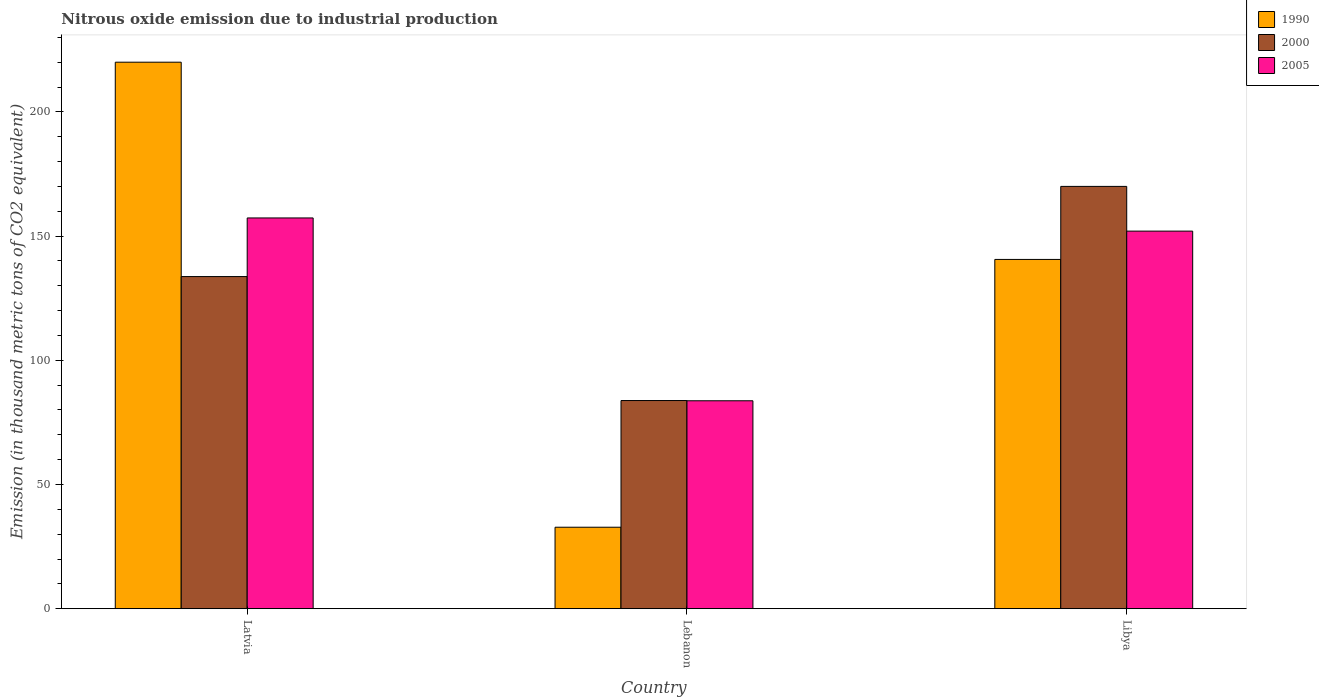How many different coloured bars are there?
Make the answer very short. 3. Are the number of bars per tick equal to the number of legend labels?
Make the answer very short. Yes. Are the number of bars on each tick of the X-axis equal?
Your response must be concise. Yes. How many bars are there on the 1st tick from the left?
Ensure brevity in your answer.  3. How many bars are there on the 1st tick from the right?
Your response must be concise. 3. What is the label of the 3rd group of bars from the left?
Provide a short and direct response. Libya. In how many cases, is the number of bars for a given country not equal to the number of legend labels?
Ensure brevity in your answer.  0. What is the amount of nitrous oxide emitted in 2000 in Latvia?
Provide a short and direct response. 133.7. Across all countries, what is the maximum amount of nitrous oxide emitted in 2000?
Your answer should be compact. 170. Across all countries, what is the minimum amount of nitrous oxide emitted in 2000?
Provide a succinct answer. 83.8. In which country was the amount of nitrous oxide emitted in 1990 maximum?
Your answer should be compact. Latvia. In which country was the amount of nitrous oxide emitted in 2005 minimum?
Keep it short and to the point. Lebanon. What is the total amount of nitrous oxide emitted in 2000 in the graph?
Your answer should be compact. 387.5. What is the difference between the amount of nitrous oxide emitted in 1990 in Lebanon and that in Libya?
Provide a succinct answer. -107.8. What is the difference between the amount of nitrous oxide emitted in 2005 in Lebanon and the amount of nitrous oxide emitted in 1990 in Libya?
Make the answer very short. -56.9. What is the average amount of nitrous oxide emitted in 1990 per country?
Your answer should be compact. 131.13. What is the difference between the amount of nitrous oxide emitted of/in 1990 and amount of nitrous oxide emitted of/in 2005 in Libya?
Your answer should be compact. -11.4. What is the ratio of the amount of nitrous oxide emitted in 2005 in Latvia to that in Libya?
Provide a short and direct response. 1.03. Is the difference between the amount of nitrous oxide emitted in 1990 in Lebanon and Libya greater than the difference between the amount of nitrous oxide emitted in 2005 in Lebanon and Libya?
Provide a succinct answer. No. What is the difference between the highest and the second highest amount of nitrous oxide emitted in 2005?
Your response must be concise. 68.3. What is the difference between the highest and the lowest amount of nitrous oxide emitted in 2000?
Provide a succinct answer. 86.2. What does the 2nd bar from the right in Latvia represents?
Ensure brevity in your answer.  2000. How many bars are there?
Give a very brief answer. 9. Are all the bars in the graph horizontal?
Your answer should be compact. No. How many countries are there in the graph?
Ensure brevity in your answer.  3. Does the graph contain any zero values?
Your answer should be compact. No. How are the legend labels stacked?
Give a very brief answer. Vertical. What is the title of the graph?
Give a very brief answer. Nitrous oxide emission due to industrial production. Does "1976" appear as one of the legend labels in the graph?
Make the answer very short. No. What is the label or title of the Y-axis?
Give a very brief answer. Emission (in thousand metric tons of CO2 equivalent). What is the Emission (in thousand metric tons of CO2 equivalent) in 1990 in Latvia?
Offer a terse response. 220. What is the Emission (in thousand metric tons of CO2 equivalent) of 2000 in Latvia?
Offer a terse response. 133.7. What is the Emission (in thousand metric tons of CO2 equivalent) of 2005 in Latvia?
Your answer should be compact. 157.3. What is the Emission (in thousand metric tons of CO2 equivalent) in 1990 in Lebanon?
Offer a very short reply. 32.8. What is the Emission (in thousand metric tons of CO2 equivalent) of 2000 in Lebanon?
Offer a very short reply. 83.8. What is the Emission (in thousand metric tons of CO2 equivalent) of 2005 in Lebanon?
Your answer should be compact. 83.7. What is the Emission (in thousand metric tons of CO2 equivalent) of 1990 in Libya?
Keep it short and to the point. 140.6. What is the Emission (in thousand metric tons of CO2 equivalent) of 2000 in Libya?
Give a very brief answer. 170. What is the Emission (in thousand metric tons of CO2 equivalent) in 2005 in Libya?
Provide a succinct answer. 152. Across all countries, what is the maximum Emission (in thousand metric tons of CO2 equivalent) of 1990?
Make the answer very short. 220. Across all countries, what is the maximum Emission (in thousand metric tons of CO2 equivalent) in 2000?
Provide a succinct answer. 170. Across all countries, what is the maximum Emission (in thousand metric tons of CO2 equivalent) in 2005?
Your answer should be very brief. 157.3. Across all countries, what is the minimum Emission (in thousand metric tons of CO2 equivalent) of 1990?
Make the answer very short. 32.8. Across all countries, what is the minimum Emission (in thousand metric tons of CO2 equivalent) of 2000?
Your answer should be compact. 83.8. Across all countries, what is the minimum Emission (in thousand metric tons of CO2 equivalent) of 2005?
Your response must be concise. 83.7. What is the total Emission (in thousand metric tons of CO2 equivalent) in 1990 in the graph?
Offer a terse response. 393.4. What is the total Emission (in thousand metric tons of CO2 equivalent) in 2000 in the graph?
Your answer should be compact. 387.5. What is the total Emission (in thousand metric tons of CO2 equivalent) in 2005 in the graph?
Your answer should be very brief. 393. What is the difference between the Emission (in thousand metric tons of CO2 equivalent) in 1990 in Latvia and that in Lebanon?
Offer a terse response. 187.2. What is the difference between the Emission (in thousand metric tons of CO2 equivalent) in 2000 in Latvia and that in Lebanon?
Provide a short and direct response. 49.9. What is the difference between the Emission (in thousand metric tons of CO2 equivalent) in 2005 in Latvia and that in Lebanon?
Provide a short and direct response. 73.6. What is the difference between the Emission (in thousand metric tons of CO2 equivalent) of 1990 in Latvia and that in Libya?
Offer a very short reply. 79.4. What is the difference between the Emission (in thousand metric tons of CO2 equivalent) of 2000 in Latvia and that in Libya?
Your answer should be very brief. -36.3. What is the difference between the Emission (in thousand metric tons of CO2 equivalent) in 2005 in Latvia and that in Libya?
Your response must be concise. 5.3. What is the difference between the Emission (in thousand metric tons of CO2 equivalent) of 1990 in Lebanon and that in Libya?
Your answer should be very brief. -107.8. What is the difference between the Emission (in thousand metric tons of CO2 equivalent) in 2000 in Lebanon and that in Libya?
Make the answer very short. -86.2. What is the difference between the Emission (in thousand metric tons of CO2 equivalent) of 2005 in Lebanon and that in Libya?
Offer a terse response. -68.3. What is the difference between the Emission (in thousand metric tons of CO2 equivalent) in 1990 in Latvia and the Emission (in thousand metric tons of CO2 equivalent) in 2000 in Lebanon?
Offer a terse response. 136.2. What is the difference between the Emission (in thousand metric tons of CO2 equivalent) of 1990 in Latvia and the Emission (in thousand metric tons of CO2 equivalent) of 2005 in Lebanon?
Make the answer very short. 136.3. What is the difference between the Emission (in thousand metric tons of CO2 equivalent) of 2000 in Latvia and the Emission (in thousand metric tons of CO2 equivalent) of 2005 in Libya?
Ensure brevity in your answer.  -18.3. What is the difference between the Emission (in thousand metric tons of CO2 equivalent) of 1990 in Lebanon and the Emission (in thousand metric tons of CO2 equivalent) of 2000 in Libya?
Offer a very short reply. -137.2. What is the difference between the Emission (in thousand metric tons of CO2 equivalent) in 1990 in Lebanon and the Emission (in thousand metric tons of CO2 equivalent) in 2005 in Libya?
Provide a short and direct response. -119.2. What is the difference between the Emission (in thousand metric tons of CO2 equivalent) in 2000 in Lebanon and the Emission (in thousand metric tons of CO2 equivalent) in 2005 in Libya?
Make the answer very short. -68.2. What is the average Emission (in thousand metric tons of CO2 equivalent) in 1990 per country?
Your response must be concise. 131.13. What is the average Emission (in thousand metric tons of CO2 equivalent) of 2000 per country?
Your response must be concise. 129.17. What is the average Emission (in thousand metric tons of CO2 equivalent) of 2005 per country?
Provide a short and direct response. 131. What is the difference between the Emission (in thousand metric tons of CO2 equivalent) of 1990 and Emission (in thousand metric tons of CO2 equivalent) of 2000 in Latvia?
Your answer should be compact. 86.3. What is the difference between the Emission (in thousand metric tons of CO2 equivalent) of 1990 and Emission (in thousand metric tons of CO2 equivalent) of 2005 in Latvia?
Provide a short and direct response. 62.7. What is the difference between the Emission (in thousand metric tons of CO2 equivalent) in 2000 and Emission (in thousand metric tons of CO2 equivalent) in 2005 in Latvia?
Give a very brief answer. -23.6. What is the difference between the Emission (in thousand metric tons of CO2 equivalent) in 1990 and Emission (in thousand metric tons of CO2 equivalent) in 2000 in Lebanon?
Offer a very short reply. -51. What is the difference between the Emission (in thousand metric tons of CO2 equivalent) of 1990 and Emission (in thousand metric tons of CO2 equivalent) of 2005 in Lebanon?
Offer a very short reply. -50.9. What is the difference between the Emission (in thousand metric tons of CO2 equivalent) of 2000 and Emission (in thousand metric tons of CO2 equivalent) of 2005 in Lebanon?
Give a very brief answer. 0.1. What is the difference between the Emission (in thousand metric tons of CO2 equivalent) of 1990 and Emission (in thousand metric tons of CO2 equivalent) of 2000 in Libya?
Give a very brief answer. -29.4. What is the difference between the Emission (in thousand metric tons of CO2 equivalent) in 1990 and Emission (in thousand metric tons of CO2 equivalent) in 2005 in Libya?
Your response must be concise. -11.4. What is the ratio of the Emission (in thousand metric tons of CO2 equivalent) of 1990 in Latvia to that in Lebanon?
Ensure brevity in your answer.  6.71. What is the ratio of the Emission (in thousand metric tons of CO2 equivalent) in 2000 in Latvia to that in Lebanon?
Your answer should be very brief. 1.6. What is the ratio of the Emission (in thousand metric tons of CO2 equivalent) of 2005 in Latvia to that in Lebanon?
Your response must be concise. 1.88. What is the ratio of the Emission (in thousand metric tons of CO2 equivalent) in 1990 in Latvia to that in Libya?
Make the answer very short. 1.56. What is the ratio of the Emission (in thousand metric tons of CO2 equivalent) in 2000 in Latvia to that in Libya?
Offer a terse response. 0.79. What is the ratio of the Emission (in thousand metric tons of CO2 equivalent) in 2005 in Latvia to that in Libya?
Make the answer very short. 1.03. What is the ratio of the Emission (in thousand metric tons of CO2 equivalent) in 1990 in Lebanon to that in Libya?
Make the answer very short. 0.23. What is the ratio of the Emission (in thousand metric tons of CO2 equivalent) in 2000 in Lebanon to that in Libya?
Your response must be concise. 0.49. What is the ratio of the Emission (in thousand metric tons of CO2 equivalent) of 2005 in Lebanon to that in Libya?
Ensure brevity in your answer.  0.55. What is the difference between the highest and the second highest Emission (in thousand metric tons of CO2 equivalent) in 1990?
Your response must be concise. 79.4. What is the difference between the highest and the second highest Emission (in thousand metric tons of CO2 equivalent) in 2000?
Your answer should be compact. 36.3. What is the difference between the highest and the second highest Emission (in thousand metric tons of CO2 equivalent) of 2005?
Your answer should be very brief. 5.3. What is the difference between the highest and the lowest Emission (in thousand metric tons of CO2 equivalent) of 1990?
Offer a very short reply. 187.2. What is the difference between the highest and the lowest Emission (in thousand metric tons of CO2 equivalent) of 2000?
Make the answer very short. 86.2. What is the difference between the highest and the lowest Emission (in thousand metric tons of CO2 equivalent) in 2005?
Your answer should be compact. 73.6. 